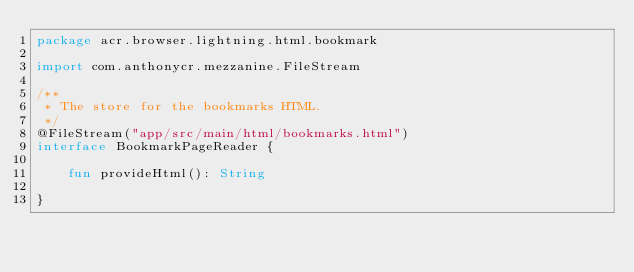<code> <loc_0><loc_0><loc_500><loc_500><_Kotlin_>package acr.browser.lightning.html.bookmark

import com.anthonycr.mezzanine.FileStream

/**
 * The store for the bookmarks HTML.
 */
@FileStream("app/src/main/html/bookmarks.html")
interface BookmarkPageReader {

    fun provideHtml(): String

}</code> 